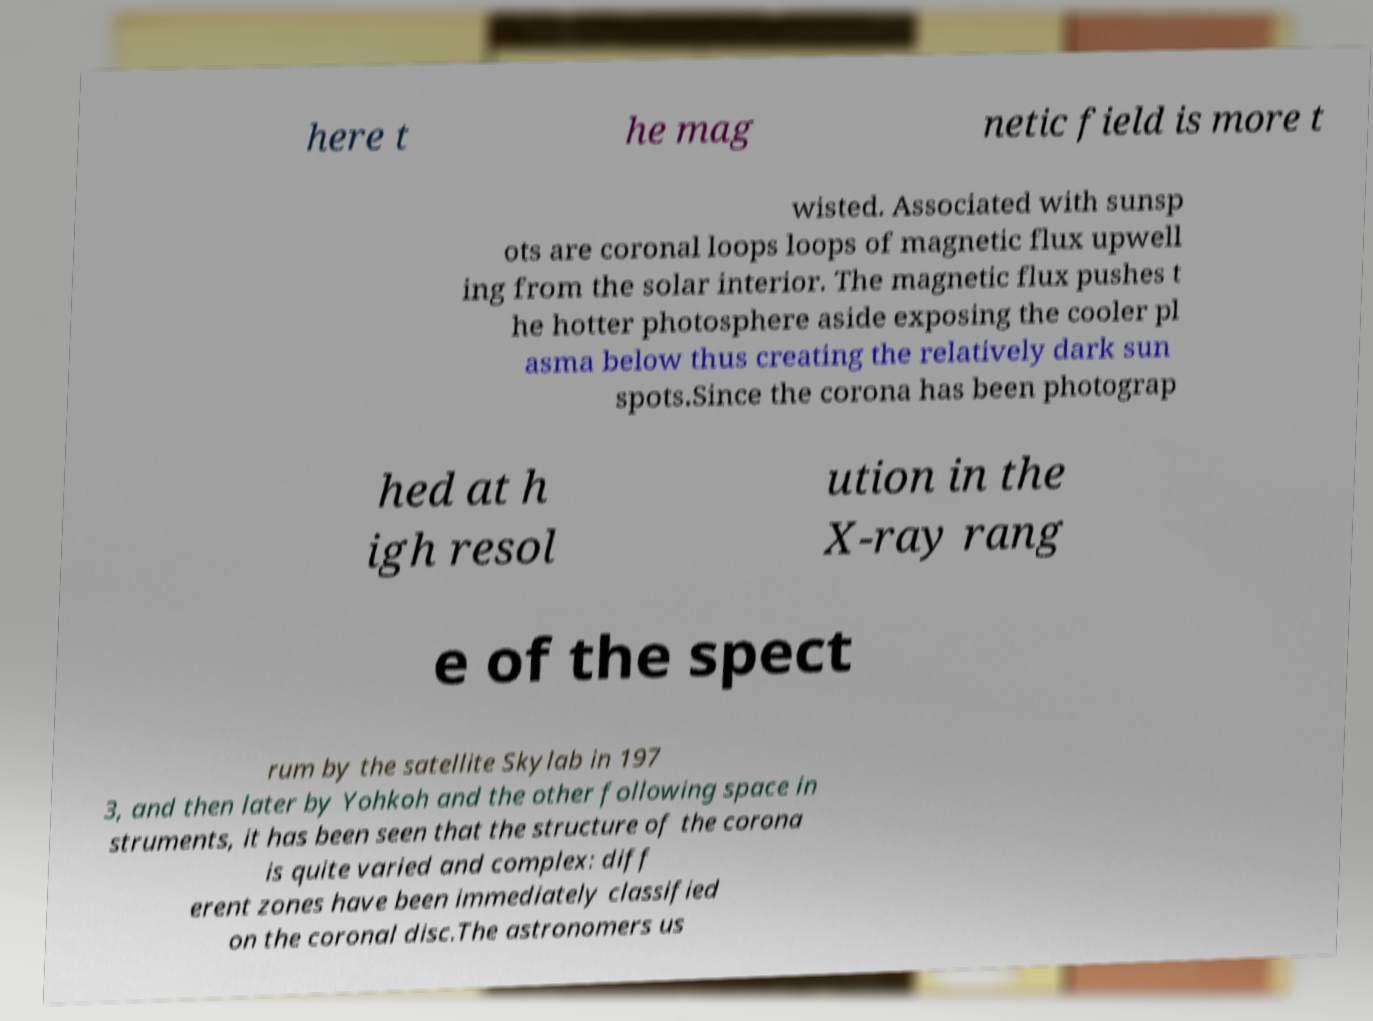Please read and relay the text visible in this image. What does it say? here t he mag netic field is more t wisted. Associated with sunsp ots are coronal loops loops of magnetic flux upwell ing from the solar interior. The magnetic flux pushes t he hotter photosphere aside exposing the cooler pl asma below thus creating the relatively dark sun spots.Since the corona has been photograp hed at h igh resol ution in the X-ray rang e of the spect rum by the satellite Skylab in 197 3, and then later by Yohkoh and the other following space in struments, it has been seen that the structure of the corona is quite varied and complex: diff erent zones have been immediately classified on the coronal disc.The astronomers us 